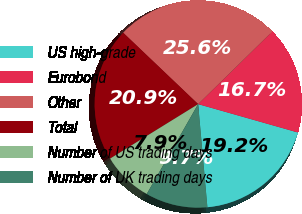<chart> <loc_0><loc_0><loc_500><loc_500><pie_chart><fcel>US high-grade<fcel>Eurobond<fcel>Other<fcel>Total<fcel>Number of US trading days<fcel>Number of UK trading days<nl><fcel>19.17%<fcel>16.74%<fcel>25.56%<fcel>20.93%<fcel>7.92%<fcel>9.69%<nl></chart> 